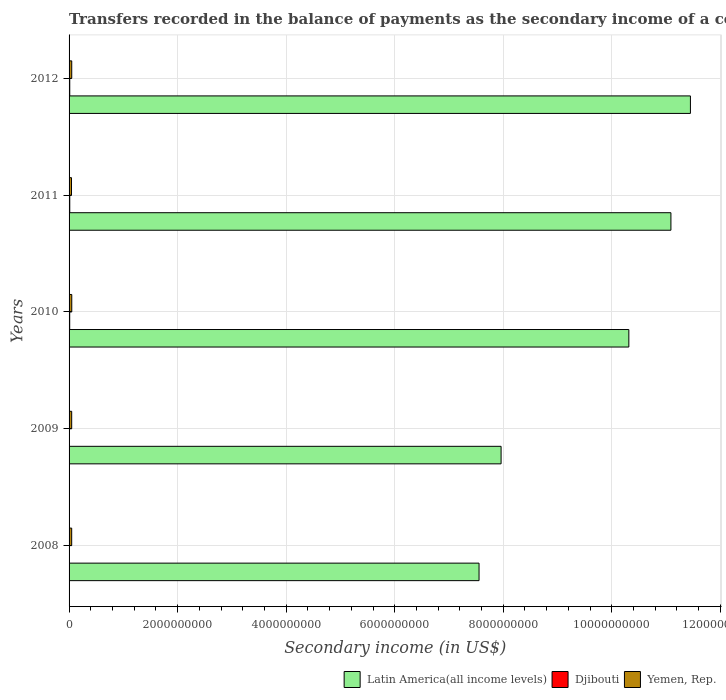How many groups of bars are there?
Provide a short and direct response. 5. Are the number of bars per tick equal to the number of legend labels?
Give a very brief answer. Yes. How many bars are there on the 5th tick from the top?
Your response must be concise. 3. How many bars are there on the 4th tick from the bottom?
Give a very brief answer. 3. In how many cases, is the number of bars for a given year not equal to the number of legend labels?
Give a very brief answer. 0. What is the secondary income of in Djibouti in 2008?
Ensure brevity in your answer.  5.12e+06. Across all years, what is the maximum secondary income of in Yemen, Rep.?
Ensure brevity in your answer.  4.97e+07. Across all years, what is the minimum secondary income of in Latin America(all income levels)?
Offer a very short reply. 7.55e+09. In which year was the secondary income of in Yemen, Rep. minimum?
Make the answer very short. 2011. What is the total secondary income of in Djibouti in the graph?
Your response must be concise. 4.78e+07. What is the difference between the secondary income of in Djibouti in 2009 and that in 2012?
Your answer should be very brief. -6.62e+06. What is the difference between the secondary income of in Latin America(all income levels) in 2009 and the secondary income of in Yemen, Rep. in 2012?
Offer a very short reply. 7.91e+09. What is the average secondary income of in Yemen, Rep. per year?
Your answer should be very brief. 4.80e+07. In the year 2011, what is the difference between the secondary income of in Latin America(all income levels) and secondary income of in Djibouti?
Your response must be concise. 1.11e+1. What is the ratio of the secondary income of in Djibouti in 2009 to that in 2010?
Provide a succinct answer. 0.5. What is the difference between the highest and the second highest secondary income of in Latin America(all income levels)?
Ensure brevity in your answer.  3.59e+08. What is the difference between the highest and the lowest secondary income of in Djibouti?
Your response must be concise. 7.74e+06. What does the 2nd bar from the top in 2010 represents?
Your answer should be compact. Djibouti. What does the 3rd bar from the bottom in 2011 represents?
Provide a short and direct response. Yemen, Rep. How many years are there in the graph?
Offer a very short reply. 5. What is the difference between two consecutive major ticks on the X-axis?
Make the answer very short. 2.00e+09. Does the graph contain grids?
Provide a succinct answer. Yes. What is the title of the graph?
Ensure brevity in your answer.  Transfers recorded in the balance of payments as the secondary income of a country. What is the label or title of the X-axis?
Give a very brief answer. Secondary income (in US$). What is the label or title of the Y-axis?
Ensure brevity in your answer.  Years. What is the Secondary income (in US$) in Latin America(all income levels) in 2008?
Your answer should be compact. 7.55e+09. What is the Secondary income (in US$) in Djibouti in 2008?
Provide a succinct answer. 5.12e+06. What is the Secondary income (in US$) in Yemen, Rep. in 2008?
Provide a succinct answer. 4.82e+07. What is the Secondary income (in US$) in Latin America(all income levels) in 2009?
Give a very brief answer. 7.96e+09. What is the Secondary income (in US$) in Djibouti in 2009?
Your response must be concise. 5.79e+06. What is the Secondary income (in US$) in Yemen, Rep. in 2009?
Ensure brevity in your answer.  4.82e+07. What is the Secondary income (in US$) in Latin America(all income levels) in 2010?
Make the answer very short. 1.03e+1. What is the Secondary income (in US$) in Djibouti in 2010?
Your answer should be compact. 1.16e+07. What is the Secondary income (in US$) of Yemen, Rep. in 2010?
Make the answer very short. 4.97e+07. What is the Secondary income (in US$) in Latin America(all income levels) in 2011?
Offer a very short reply. 1.11e+1. What is the Secondary income (in US$) of Djibouti in 2011?
Your answer should be compact. 1.29e+07. What is the Secondary income (in US$) in Yemen, Rep. in 2011?
Provide a short and direct response. 4.48e+07. What is the Secondary income (in US$) of Latin America(all income levels) in 2012?
Give a very brief answer. 1.14e+1. What is the Secondary income (in US$) of Djibouti in 2012?
Provide a short and direct response. 1.24e+07. What is the Secondary income (in US$) of Yemen, Rep. in 2012?
Your response must be concise. 4.91e+07. Across all years, what is the maximum Secondary income (in US$) of Latin America(all income levels)?
Keep it short and to the point. 1.14e+1. Across all years, what is the maximum Secondary income (in US$) in Djibouti?
Provide a short and direct response. 1.29e+07. Across all years, what is the maximum Secondary income (in US$) in Yemen, Rep.?
Your answer should be very brief. 4.97e+07. Across all years, what is the minimum Secondary income (in US$) in Latin America(all income levels)?
Offer a very short reply. 7.55e+09. Across all years, what is the minimum Secondary income (in US$) in Djibouti?
Offer a terse response. 5.12e+06. Across all years, what is the minimum Secondary income (in US$) of Yemen, Rep.?
Provide a short and direct response. 4.48e+07. What is the total Secondary income (in US$) in Latin America(all income levels) in the graph?
Your answer should be very brief. 4.84e+1. What is the total Secondary income (in US$) in Djibouti in the graph?
Give a very brief answer. 4.78e+07. What is the total Secondary income (in US$) in Yemen, Rep. in the graph?
Ensure brevity in your answer.  2.40e+08. What is the difference between the Secondary income (in US$) of Latin America(all income levels) in 2008 and that in 2009?
Your response must be concise. -4.06e+08. What is the difference between the Secondary income (in US$) in Djibouti in 2008 and that in 2009?
Provide a short and direct response. -6.70e+05. What is the difference between the Secondary income (in US$) of Yemen, Rep. in 2008 and that in 2009?
Keep it short and to the point. 0. What is the difference between the Secondary income (in US$) in Latin America(all income levels) in 2008 and that in 2010?
Provide a succinct answer. -2.76e+09. What is the difference between the Secondary income (in US$) of Djibouti in 2008 and that in 2010?
Keep it short and to the point. -6.50e+06. What is the difference between the Secondary income (in US$) of Yemen, Rep. in 2008 and that in 2010?
Your answer should be very brief. -1.48e+06. What is the difference between the Secondary income (in US$) in Latin America(all income levels) in 2008 and that in 2011?
Offer a terse response. -3.54e+09. What is the difference between the Secondary income (in US$) in Djibouti in 2008 and that in 2011?
Ensure brevity in your answer.  -7.74e+06. What is the difference between the Secondary income (in US$) of Yemen, Rep. in 2008 and that in 2011?
Your answer should be very brief. 3.42e+06. What is the difference between the Secondary income (in US$) in Latin America(all income levels) in 2008 and that in 2012?
Your answer should be compact. -3.89e+09. What is the difference between the Secondary income (in US$) of Djibouti in 2008 and that in 2012?
Provide a short and direct response. -7.29e+06. What is the difference between the Secondary income (in US$) of Yemen, Rep. in 2008 and that in 2012?
Give a very brief answer. -8.67e+05. What is the difference between the Secondary income (in US$) in Latin America(all income levels) in 2009 and that in 2010?
Ensure brevity in your answer.  -2.35e+09. What is the difference between the Secondary income (in US$) of Djibouti in 2009 and that in 2010?
Provide a short and direct response. -5.83e+06. What is the difference between the Secondary income (in US$) of Yemen, Rep. in 2009 and that in 2010?
Offer a terse response. -1.48e+06. What is the difference between the Secondary income (in US$) of Latin America(all income levels) in 2009 and that in 2011?
Give a very brief answer. -3.13e+09. What is the difference between the Secondary income (in US$) in Djibouti in 2009 and that in 2011?
Provide a succinct answer. -7.07e+06. What is the difference between the Secondary income (in US$) of Yemen, Rep. in 2009 and that in 2011?
Give a very brief answer. 3.42e+06. What is the difference between the Secondary income (in US$) of Latin America(all income levels) in 2009 and that in 2012?
Offer a very short reply. -3.49e+09. What is the difference between the Secondary income (in US$) in Djibouti in 2009 and that in 2012?
Provide a short and direct response. -6.62e+06. What is the difference between the Secondary income (in US$) in Yemen, Rep. in 2009 and that in 2012?
Make the answer very short. -8.67e+05. What is the difference between the Secondary income (in US$) of Latin America(all income levels) in 2010 and that in 2011?
Make the answer very short. -7.75e+08. What is the difference between the Secondary income (in US$) of Djibouti in 2010 and that in 2011?
Give a very brief answer. -1.24e+06. What is the difference between the Secondary income (in US$) of Yemen, Rep. in 2010 and that in 2011?
Your answer should be compact. 4.90e+06. What is the difference between the Secondary income (in US$) in Latin America(all income levels) in 2010 and that in 2012?
Provide a short and direct response. -1.13e+09. What is the difference between the Secondary income (in US$) in Djibouti in 2010 and that in 2012?
Provide a short and direct response. -7.88e+05. What is the difference between the Secondary income (in US$) in Yemen, Rep. in 2010 and that in 2012?
Offer a very short reply. 6.13e+05. What is the difference between the Secondary income (in US$) of Latin America(all income levels) in 2011 and that in 2012?
Provide a succinct answer. -3.59e+08. What is the difference between the Secondary income (in US$) of Djibouti in 2011 and that in 2012?
Your response must be concise. 4.50e+05. What is the difference between the Secondary income (in US$) in Yemen, Rep. in 2011 and that in 2012?
Offer a very short reply. -4.29e+06. What is the difference between the Secondary income (in US$) in Latin America(all income levels) in 2008 and the Secondary income (in US$) in Djibouti in 2009?
Your answer should be very brief. 7.55e+09. What is the difference between the Secondary income (in US$) in Latin America(all income levels) in 2008 and the Secondary income (in US$) in Yemen, Rep. in 2009?
Offer a terse response. 7.51e+09. What is the difference between the Secondary income (in US$) in Djibouti in 2008 and the Secondary income (in US$) in Yemen, Rep. in 2009?
Offer a terse response. -4.31e+07. What is the difference between the Secondary income (in US$) of Latin America(all income levels) in 2008 and the Secondary income (in US$) of Djibouti in 2010?
Keep it short and to the point. 7.54e+09. What is the difference between the Secondary income (in US$) in Latin America(all income levels) in 2008 and the Secondary income (in US$) in Yemen, Rep. in 2010?
Ensure brevity in your answer.  7.50e+09. What is the difference between the Secondary income (in US$) of Djibouti in 2008 and the Secondary income (in US$) of Yemen, Rep. in 2010?
Your answer should be very brief. -4.46e+07. What is the difference between the Secondary income (in US$) in Latin America(all income levels) in 2008 and the Secondary income (in US$) in Djibouti in 2011?
Provide a short and direct response. 7.54e+09. What is the difference between the Secondary income (in US$) of Latin America(all income levels) in 2008 and the Secondary income (in US$) of Yemen, Rep. in 2011?
Provide a succinct answer. 7.51e+09. What is the difference between the Secondary income (in US$) in Djibouti in 2008 and the Secondary income (in US$) in Yemen, Rep. in 2011?
Give a very brief answer. -3.97e+07. What is the difference between the Secondary income (in US$) in Latin America(all income levels) in 2008 and the Secondary income (in US$) in Djibouti in 2012?
Your answer should be compact. 7.54e+09. What is the difference between the Secondary income (in US$) in Latin America(all income levels) in 2008 and the Secondary income (in US$) in Yemen, Rep. in 2012?
Make the answer very short. 7.50e+09. What is the difference between the Secondary income (in US$) of Djibouti in 2008 and the Secondary income (in US$) of Yemen, Rep. in 2012?
Your response must be concise. -4.40e+07. What is the difference between the Secondary income (in US$) in Latin America(all income levels) in 2009 and the Secondary income (in US$) in Djibouti in 2010?
Provide a short and direct response. 7.95e+09. What is the difference between the Secondary income (in US$) of Latin America(all income levels) in 2009 and the Secondary income (in US$) of Yemen, Rep. in 2010?
Your answer should be compact. 7.91e+09. What is the difference between the Secondary income (in US$) in Djibouti in 2009 and the Secondary income (in US$) in Yemen, Rep. in 2010?
Your answer should be very brief. -4.39e+07. What is the difference between the Secondary income (in US$) in Latin America(all income levels) in 2009 and the Secondary income (in US$) in Djibouti in 2011?
Give a very brief answer. 7.95e+09. What is the difference between the Secondary income (in US$) in Latin America(all income levels) in 2009 and the Secondary income (in US$) in Yemen, Rep. in 2011?
Provide a succinct answer. 7.91e+09. What is the difference between the Secondary income (in US$) of Djibouti in 2009 and the Secondary income (in US$) of Yemen, Rep. in 2011?
Keep it short and to the point. -3.90e+07. What is the difference between the Secondary income (in US$) of Latin America(all income levels) in 2009 and the Secondary income (in US$) of Djibouti in 2012?
Offer a very short reply. 7.95e+09. What is the difference between the Secondary income (in US$) of Latin America(all income levels) in 2009 and the Secondary income (in US$) of Yemen, Rep. in 2012?
Your response must be concise. 7.91e+09. What is the difference between the Secondary income (in US$) in Djibouti in 2009 and the Secondary income (in US$) in Yemen, Rep. in 2012?
Offer a very short reply. -4.33e+07. What is the difference between the Secondary income (in US$) of Latin America(all income levels) in 2010 and the Secondary income (in US$) of Djibouti in 2011?
Your response must be concise. 1.03e+1. What is the difference between the Secondary income (in US$) in Latin America(all income levels) in 2010 and the Secondary income (in US$) in Yemen, Rep. in 2011?
Provide a short and direct response. 1.03e+1. What is the difference between the Secondary income (in US$) of Djibouti in 2010 and the Secondary income (in US$) of Yemen, Rep. in 2011?
Give a very brief answer. -3.32e+07. What is the difference between the Secondary income (in US$) of Latin America(all income levels) in 2010 and the Secondary income (in US$) of Djibouti in 2012?
Your answer should be very brief. 1.03e+1. What is the difference between the Secondary income (in US$) in Latin America(all income levels) in 2010 and the Secondary income (in US$) in Yemen, Rep. in 2012?
Your answer should be compact. 1.03e+1. What is the difference between the Secondary income (in US$) of Djibouti in 2010 and the Secondary income (in US$) of Yemen, Rep. in 2012?
Provide a short and direct response. -3.75e+07. What is the difference between the Secondary income (in US$) in Latin America(all income levels) in 2011 and the Secondary income (in US$) in Djibouti in 2012?
Your answer should be very brief. 1.11e+1. What is the difference between the Secondary income (in US$) in Latin America(all income levels) in 2011 and the Secondary income (in US$) in Yemen, Rep. in 2012?
Give a very brief answer. 1.10e+1. What is the difference between the Secondary income (in US$) of Djibouti in 2011 and the Secondary income (in US$) of Yemen, Rep. in 2012?
Ensure brevity in your answer.  -3.62e+07. What is the average Secondary income (in US$) in Latin America(all income levels) per year?
Ensure brevity in your answer.  9.67e+09. What is the average Secondary income (in US$) of Djibouti per year?
Keep it short and to the point. 9.56e+06. What is the average Secondary income (in US$) of Yemen, Rep. per year?
Offer a very short reply. 4.80e+07. In the year 2008, what is the difference between the Secondary income (in US$) of Latin America(all income levels) and Secondary income (in US$) of Djibouti?
Keep it short and to the point. 7.55e+09. In the year 2008, what is the difference between the Secondary income (in US$) in Latin America(all income levels) and Secondary income (in US$) in Yemen, Rep.?
Ensure brevity in your answer.  7.51e+09. In the year 2008, what is the difference between the Secondary income (in US$) in Djibouti and Secondary income (in US$) in Yemen, Rep.?
Provide a short and direct response. -4.31e+07. In the year 2009, what is the difference between the Secondary income (in US$) of Latin America(all income levels) and Secondary income (in US$) of Djibouti?
Your answer should be very brief. 7.95e+09. In the year 2009, what is the difference between the Secondary income (in US$) of Latin America(all income levels) and Secondary income (in US$) of Yemen, Rep.?
Provide a succinct answer. 7.91e+09. In the year 2009, what is the difference between the Secondary income (in US$) in Djibouti and Secondary income (in US$) in Yemen, Rep.?
Offer a terse response. -4.25e+07. In the year 2010, what is the difference between the Secondary income (in US$) of Latin America(all income levels) and Secondary income (in US$) of Djibouti?
Your answer should be compact. 1.03e+1. In the year 2010, what is the difference between the Secondary income (in US$) in Latin America(all income levels) and Secondary income (in US$) in Yemen, Rep.?
Keep it short and to the point. 1.03e+1. In the year 2010, what is the difference between the Secondary income (in US$) of Djibouti and Secondary income (in US$) of Yemen, Rep.?
Provide a short and direct response. -3.81e+07. In the year 2011, what is the difference between the Secondary income (in US$) of Latin America(all income levels) and Secondary income (in US$) of Djibouti?
Ensure brevity in your answer.  1.11e+1. In the year 2011, what is the difference between the Secondary income (in US$) in Latin America(all income levels) and Secondary income (in US$) in Yemen, Rep.?
Ensure brevity in your answer.  1.10e+1. In the year 2011, what is the difference between the Secondary income (in US$) in Djibouti and Secondary income (in US$) in Yemen, Rep.?
Keep it short and to the point. -3.20e+07. In the year 2012, what is the difference between the Secondary income (in US$) of Latin America(all income levels) and Secondary income (in US$) of Djibouti?
Offer a terse response. 1.14e+1. In the year 2012, what is the difference between the Secondary income (in US$) of Latin America(all income levels) and Secondary income (in US$) of Yemen, Rep.?
Your answer should be very brief. 1.14e+1. In the year 2012, what is the difference between the Secondary income (in US$) of Djibouti and Secondary income (in US$) of Yemen, Rep.?
Provide a succinct answer. -3.67e+07. What is the ratio of the Secondary income (in US$) of Latin America(all income levels) in 2008 to that in 2009?
Offer a very short reply. 0.95. What is the ratio of the Secondary income (in US$) of Djibouti in 2008 to that in 2009?
Your answer should be very brief. 0.88. What is the ratio of the Secondary income (in US$) of Latin America(all income levels) in 2008 to that in 2010?
Your answer should be very brief. 0.73. What is the ratio of the Secondary income (in US$) of Djibouti in 2008 to that in 2010?
Make the answer very short. 0.44. What is the ratio of the Secondary income (in US$) of Yemen, Rep. in 2008 to that in 2010?
Your answer should be compact. 0.97. What is the ratio of the Secondary income (in US$) of Latin America(all income levels) in 2008 to that in 2011?
Ensure brevity in your answer.  0.68. What is the ratio of the Secondary income (in US$) in Djibouti in 2008 to that in 2011?
Ensure brevity in your answer.  0.4. What is the ratio of the Secondary income (in US$) of Yemen, Rep. in 2008 to that in 2011?
Your answer should be compact. 1.08. What is the ratio of the Secondary income (in US$) of Latin America(all income levels) in 2008 to that in 2012?
Ensure brevity in your answer.  0.66. What is the ratio of the Secondary income (in US$) in Djibouti in 2008 to that in 2012?
Keep it short and to the point. 0.41. What is the ratio of the Secondary income (in US$) of Yemen, Rep. in 2008 to that in 2012?
Keep it short and to the point. 0.98. What is the ratio of the Secondary income (in US$) of Latin America(all income levels) in 2009 to that in 2010?
Your response must be concise. 0.77. What is the ratio of the Secondary income (in US$) in Djibouti in 2009 to that in 2010?
Your answer should be compact. 0.5. What is the ratio of the Secondary income (in US$) of Yemen, Rep. in 2009 to that in 2010?
Your response must be concise. 0.97. What is the ratio of the Secondary income (in US$) of Latin America(all income levels) in 2009 to that in 2011?
Ensure brevity in your answer.  0.72. What is the ratio of the Secondary income (in US$) of Djibouti in 2009 to that in 2011?
Your response must be concise. 0.45. What is the ratio of the Secondary income (in US$) of Yemen, Rep. in 2009 to that in 2011?
Provide a short and direct response. 1.08. What is the ratio of the Secondary income (in US$) in Latin America(all income levels) in 2009 to that in 2012?
Provide a succinct answer. 0.7. What is the ratio of the Secondary income (in US$) of Djibouti in 2009 to that in 2012?
Ensure brevity in your answer.  0.47. What is the ratio of the Secondary income (in US$) of Yemen, Rep. in 2009 to that in 2012?
Ensure brevity in your answer.  0.98. What is the ratio of the Secondary income (in US$) in Latin America(all income levels) in 2010 to that in 2011?
Your answer should be very brief. 0.93. What is the ratio of the Secondary income (in US$) in Djibouti in 2010 to that in 2011?
Offer a terse response. 0.9. What is the ratio of the Secondary income (in US$) of Yemen, Rep. in 2010 to that in 2011?
Make the answer very short. 1.11. What is the ratio of the Secondary income (in US$) in Latin America(all income levels) in 2010 to that in 2012?
Make the answer very short. 0.9. What is the ratio of the Secondary income (in US$) in Djibouti in 2010 to that in 2012?
Your response must be concise. 0.94. What is the ratio of the Secondary income (in US$) in Yemen, Rep. in 2010 to that in 2012?
Provide a short and direct response. 1.01. What is the ratio of the Secondary income (in US$) in Latin America(all income levels) in 2011 to that in 2012?
Your answer should be very brief. 0.97. What is the ratio of the Secondary income (in US$) in Djibouti in 2011 to that in 2012?
Offer a very short reply. 1.04. What is the ratio of the Secondary income (in US$) of Yemen, Rep. in 2011 to that in 2012?
Offer a terse response. 0.91. What is the difference between the highest and the second highest Secondary income (in US$) in Latin America(all income levels)?
Provide a short and direct response. 3.59e+08. What is the difference between the highest and the second highest Secondary income (in US$) in Djibouti?
Provide a succinct answer. 4.50e+05. What is the difference between the highest and the second highest Secondary income (in US$) of Yemen, Rep.?
Your answer should be compact. 6.13e+05. What is the difference between the highest and the lowest Secondary income (in US$) of Latin America(all income levels)?
Ensure brevity in your answer.  3.89e+09. What is the difference between the highest and the lowest Secondary income (in US$) in Djibouti?
Provide a succinct answer. 7.74e+06. What is the difference between the highest and the lowest Secondary income (in US$) of Yemen, Rep.?
Your response must be concise. 4.90e+06. 